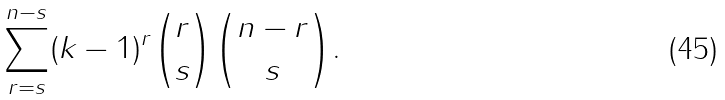<formula> <loc_0><loc_0><loc_500><loc_500>\sum _ { r = s } ^ { n - s } ( k - 1 ) ^ { r } \binom { r } { s } \binom { n - r } { s } .</formula> 